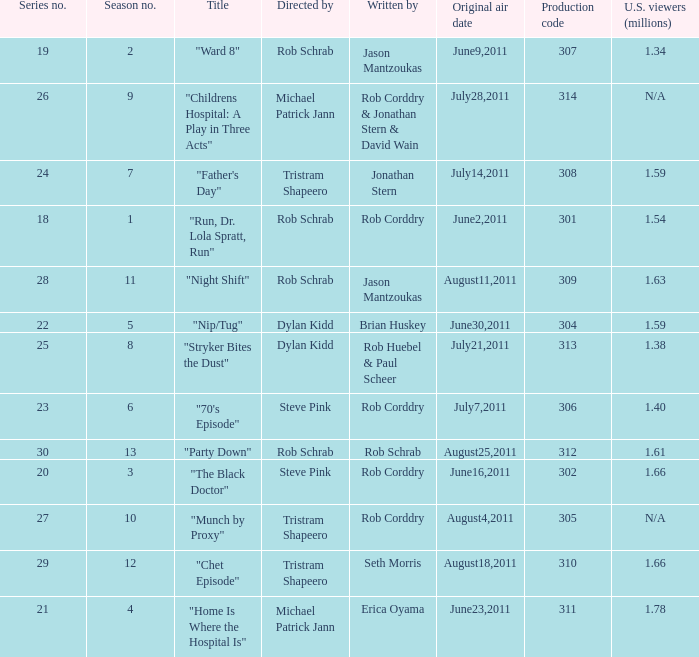Can you parse all the data within this table? {'header': ['Series no.', 'Season no.', 'Title', 'Directed by', 'Written by', 'Original air date', 'Production code', 'U.S. viewers (millions)'], 'rows': [['19', '2', '"Ward 8"', 'Rob Schrab', 'Jason Mantzoukas', 'June9,2011', '307', '1.34'], ['26', '9', '"Childrens Hospital: A Play in Three Acts"', 'Michael Patrick Jann', 'Rob Corddry & Jonathan Stern & David Wain', 'July28,2011', '314', 'N/A'], ['24', '7', '"Father\'s Day"', 'Tristram Shapeero', 'Jonathan Stern', 'July14,2011', '308', '1.59'], ['18', '1', '"Run, Dr. Lola Spratt, Run"', 'Rob Schrab', 'Rob Corddry', 'June2,2011', '301', '1.54'], ['28', '11', '"Night Shift"', 'Rob Schrab', 'Jason Mantzoukas', 'August11,2011', '309', '1.63'], ['22', '5', '"Nip/Tug"', 'Dylan Kidd', 'Brian Huskey', 'June30,2011', '304', '1.59'], ['25', '8', '"Stryker Bites the Dust"', 'Dylan Kidd', 'Rob Huebel & Paul Scheer', 'July21,2011', '313', '1.38'], ['23', '6', '"70\'s Episode"', 'Steve Pink', 'Rob Corddry', 'July7,2011', '306', '1.40'], ['30', '13', '"Party Down"', 'Rob Schrab', 'Rob Schrab', 'August25,2011', '312', '1.61'], ['20', '3', '"The Black Doctor"', 'Steve Pink', 'Rob Corddry', 'June16,2011', '302', '1.66'], ['27', '10', '"Munch by Proxy"', 'Tristram Shapeero', 'Rob Corddry', 'August4,2011', '305', 'N/A'], ['29', '12', '"Chet Episode"', 'Tristram Shapeero', 'Seth Morris', 'August18,2011', '310', '1.66'], ['21', '4', '"Home Is Where the Hospital Is"', 'Michael Patrick Jann', 'Erica Oyama', 'June23,2011', '311', '1.78']]} At most what number in the series was the episode "chet episode"? 29.0. 